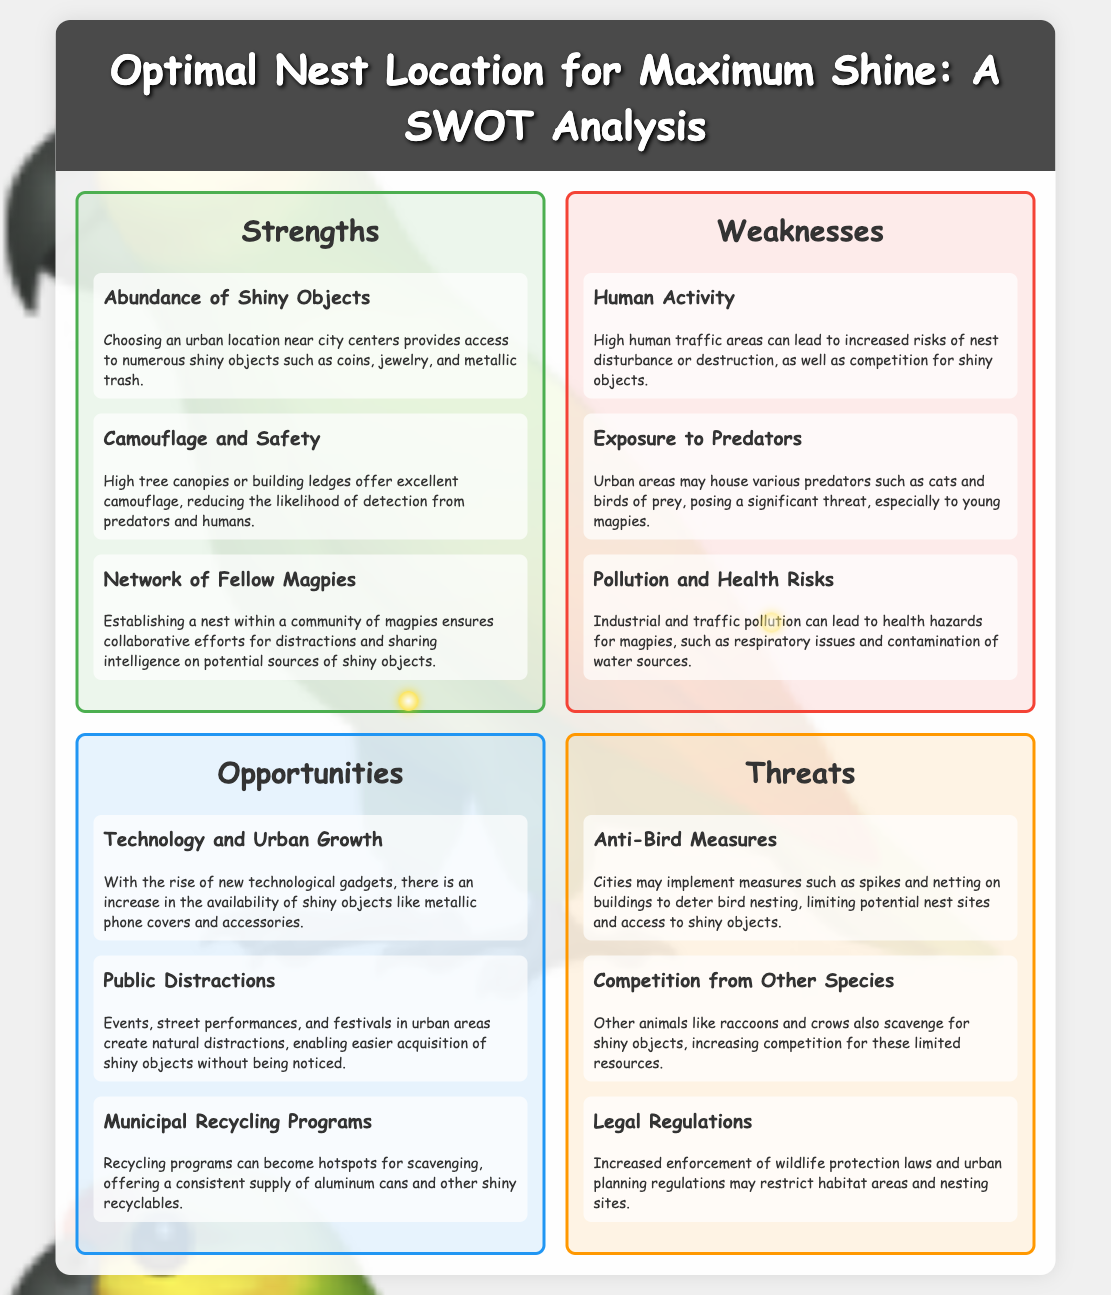What are the three strengths listed? The strengths section includes three items that highlight the advantages of optimal nest location for magpies.
Answer: Abundance of Shiny Objects, Camouflage and Safety, Network of Fellow Magpies What is one weakness related to human activity? The weaknesses section discusses potential issues magpies may face in urban environments, especially concerning human presence.
Answer: High human traffic areas can lead to increased risks of nest disturbance or destruction, as well as competition for shiny objects What is one opportunity presented by urban growth? The opportunities section mentions how urban development can provide more items of interest for magpies.
Answer: Increase in the availability of shiny objects like metallic phone covers and accessories What is a major threat listed that relates to bird measures? The threats section outlines various dangers to magpies in urban settings and one is specifically anti-bird measures.
Answer: Cities may implement measures such as spikes and netting on buildings to deter bird nesting How many total sections are in the SWOT analysis? The document contains four distinct sections, each addressing a component of the SWOT analysis.
Answer: Four 